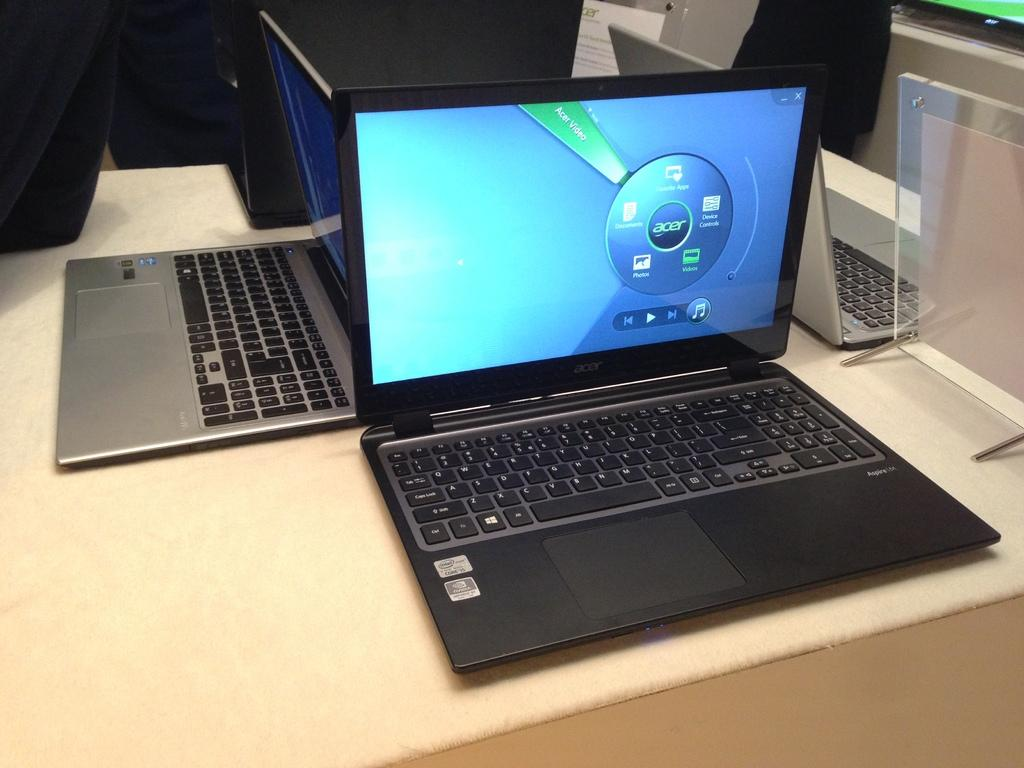<image>
Write a terse but informative summary of the picture. Acer Laptop that has the opening windows screen on it, with a multimedia player. 